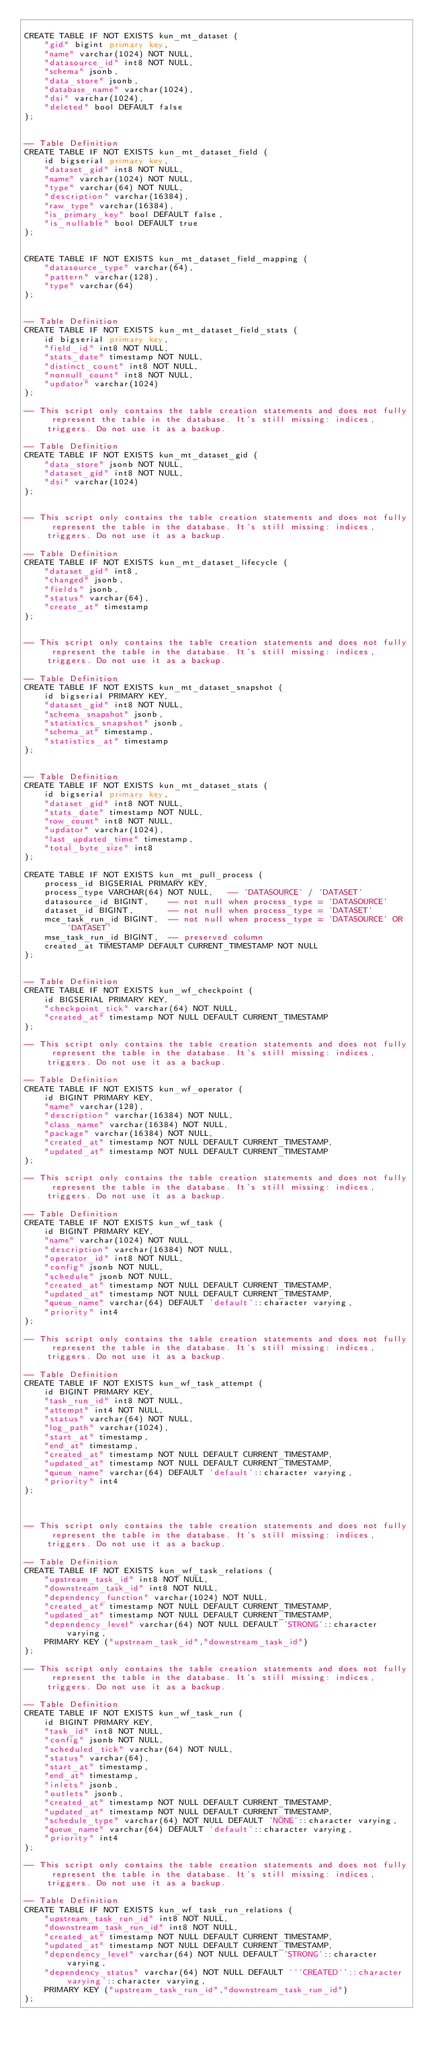Convert code to text. <code><loc_0><loc_0><loc_500><loc_500><_SQL_>
CREATE TABLE IF NOT EXISTS kun_mt_dataset (
    "gid" bigint primary key,
    "name" varchar(1024) NOT NULL,
    "datasource_id" int8 NOT NULL,
    "schema" jsonb,
    "data_store" jsonb,
    "database_name" varchar(1024),
    "dsi" varchar(1024),
    "deleted" bool DEFAULT false
);


-- Table Definition
CREATE TABLE IF NOT EXISTS kun_mt_dataset_field (
    id bigserial primary key,
    "dataset_gid" int8 NOT NULL,
    "name" varchar(1024) NOT NULL,
    "type" varchar(64) NOT NULL,
    "description" varchar(16384),
    "raw_type" varchar(16384),
    "is_primary_key" bool DEFAULT false,
    "is_nullable" bool DEFAULT true
);


CREATE TABLE IF NOT EXISTS kun_mt_dataset_field_mapping (
    "datasource_type" varchar(64),
    "pattern" varchar(128),
    "type" varchar(64)
);


-- Table Definition
CREATE TABLE IF NOT EXISTS kun_mt_dataset_field_stats (
    id bigserial primary key,
    "field_id" int8 NOT NULL,
    "stats_date" timestamp NOT NULL,
    "distinct_count" int8 NOT NULL,
    "nonnull_count" int8 NOT NULL,
    "updator" varchar(1024)
);

-- This script only contains the table creation statements and does not fully represent the table in the database. It's still missing: indices, triggers. Do not use it as a backup.

-- Table Definition
CREATE TABLE IF NOT EXISTS kun_mt_dataset_gid (
    "data_store" jsonb NOT NULL,
    "dataset_gid" int8 NOT NULL,
    "dsi" varchar(1024)
);


-- This script only contains the table creation statements and does not fully represent the table in the database. It's still missing: indices, triggers. Do not use it as a backup.

-- Table Definition
CREATE TABLE IF NOT EXISTS kun_mt_dataset_lifecycle (
    "dataset_gid" int8,
    "changed" jsonb,
    "fields" jsonb,
    "status" varchar(64),
    "create_at" timestamp
);


-- This script only contains the table creation statements and does not fully represent the table in the database. It's still missing: indices, triggers. Do not use it as a backup.

-- Table Definition
CREATE TABLE IF NOT EXISTS kun_mt_dataset_snapshot (
    id bigserial PRIMARY KEY,
    "dataset_gid" int8 NOT NULL,
    "schema_snapshot" jsonb,
    "statistics_snapshot" jsonb,
    "schema_at" timestamp,
    "statistics_at" timestamp
);


-- Table Definition
CREATE TABLE IF NOT EXISTS kun_mt_dataset_stats (
    id bigserial primary key,
    "dataset_gid" int8 NOT NULL,
    "stats_date" timestamp NOT NULL,
    "row_count" int8 NOT NULL,
    "updator" varchar(1024),
    "last_updated_time" timestamp,
    "total_byte_size" int8
);

CREATE TABLE IF NOT EXISTS kun_mt_pull_process (
    process_id BIGSERIAL PRIMARY KEY,
    process_type VARCHAR(64) NOT NULL,   -- 'DATASOURCE' / 'DATASET'
    datasource_id BIGINT,    -- not null when process_type = 'DATASOURCE'
    dataset_id BIGINT,       -- not null when process_type = 'DATASET'
    mce_task_run_id BIGINT,  -- not null when process_type = 'DATASOURCE' OR 'DATASET'
    mse_task_run_id BIGINT,  -- preserved column
    created_at TIMESTAMP DEFAULT CURRENT_TIMESTAMP NOT NULL
);


-- Table Definition
CREATE TABLE IF NOT EXISTS kun_wf_checkpoint (
    id BIGSERIAL PRIMARY KEY,
    "checkpoint_tick" varchar(64) NOT NULL,
    "created_at" timestamp NOT NULL DEFAULT CURRENT_TIMESTAMP
);

-- This script only contains the table creation statements and does not fully represent the table in the database. It's still missing: indices, triggers. Do not use it as a backup.

-- Table Definition
CREATE TABLE IF NOT EXISTS kun_wf_operator (
    id BIGINT PRIMARY KEY,
    "name" varchar(128),
    "description" varchar(16384) NOT NULL,
    "class_name" varchar(16384) NOT NULL,
    "package" varchar(16384) NOT NULL,
    "created_at" timestamp NOT NULL DEFAULT CURRENT_TIMESTAMP,
    "updated_at" timestamp NOT NULL DEFAULT CURRENT_TIMESTAMP
);

-- This script only contains the table creation statements and does not fully represent the table in the database. It's still missing: indices, triggers. Do not use it as a backup.

-- Table Definition
CREATE TABLE IF NOT EXISTS kun_wf_task (
    id BIGINT PRIMARY KEY,
    "name" varchar(1024) NOT NULL,
    "description" varchar(16384) NOT NULL,
    "operator_id" int8 NOT NULL,
    "config" jsonb NOT NULL,
    "schedule" jsonb NOT NULL,
    "created_at" timestamp NOT NULL DEFAULT CURRENT_TIMESTAMP,
    "updated_at" timestamp NOT NULL DEFAULT CURRENT_TIMESTAMP,
    "queue_name" varchar(64) DEFAULT 'default'::character varying,
    "priority" int4
);

-- This script only contains the table creation statements and does not fully represent the table in the database. It's still missing: indices, triggers. Do not use it as a backup.

-- Table Definition
CREATE TABLE IF NOT EXISTS kun_wf_task_attempt (
    id BIGINT PRIMARY KEY,
    "task_run_id" int8 NOT NULL,
    "attempt" int4 NOT NULL,
    "status" varchar(64) NOT NULL,
    "log_path" varchar(1024),
    "start_at" timestamp,
    "end_at" timestamp,
    "created_at" timestamp NOT NULL DEFAULT CURRENT_TIMESTAMP,
    "updated_at" timestamp NOT NULL DEFAULT CURRENT_TIMESTAMP,
    "queue_name" varchar(64) DEFAULT 'default'::character varying,
    "priority" int4
);



-- This script only contains the table creation statements and does not fully represent the table in the database. It's still missing: indices, triggers. Do not use it as a backup.

-- Table Definition
CREATE TABLE IF NOT EXISTS kun_wf_task_relations (
    "upstream_task_id" int8 NOT NULL,
    "downstream_task_id" int8 NOT NULL,
    "dependency_function" varchar(1024) NOT NULL,
    "created_at" timestamp NOT NULL DEFAULT CURRENT_TIMESTAMP,
    "updated_at" timestamp NOT NULL DEFAULT CURRENT_TIMESTAMP,
    "dependency_level" varchar(64) NOT NULL DEFAULT 'STRONG'::character varying,
    PRIMARY KEY ("upstream_task_id","downstream_task_id")
);

-- This script only contains the table creation statements and does not fully represent the table in the database. It's still missing: indices, triggers. Do not use it as a backup.

-- Table Definition
CREATE TABLE IF NOT EXISTS kun_wf_task_run (
    id BIGINT PRIMARY KEY,
    "task_id" int8 NOT NULL,
    "config" jsonb NOT NULL,
    "scheduled_tick" varchar(64) NOT NULL,
    "status" varchar(64),
    "start_at" timestamp,
    "end_at" timestamp,
    "inlets" jsonb,
    "outlets" jsonb,
    "created_at" timestamp NOT NULL DEFAULT CURRENT_TIMESTAMP,
    "updated_at" timestamp NOT NULL DEFAULT CURRENT_TIMESTAMP,
    "schedule_type" varchar(64) NOT NULL DEFAULT 'NONE'::character varying,
    "queue_name" varchar(64) DEFAULT 'default'::character varying,
    "priority" int4
);

-- This script only contains the table creation statements and does not fully represent the table in the database. It's still missing: indices, triggers. Do not use it as a backup.

-- Table Definition
CREATE TABLE IF NOT EXISTS kun_wf_task_run_relations (
    "upstream_task_run_id" int8 NOT NULL,
    "downstream_task_run_id" int8 NOT NULL,
    "created_at" timestamp NOT NULL DEFAULT CURRENT_TIMESTAMP,
    "updated_at" timestamp NOT NULL DEFAULT CURRENT_TIMESTAMP,
    "dependency_level" varchar(64) NOT NULL DEFAULT 'STRONG'::character varying,
    "dependency_status" varchar(64) NOT NULL DEFAULT '''CREATED''::character varying'::character varying,
    PRIMARY KEY ("upstream_task_run_id","downstream_task_run_id")
);
</code> 